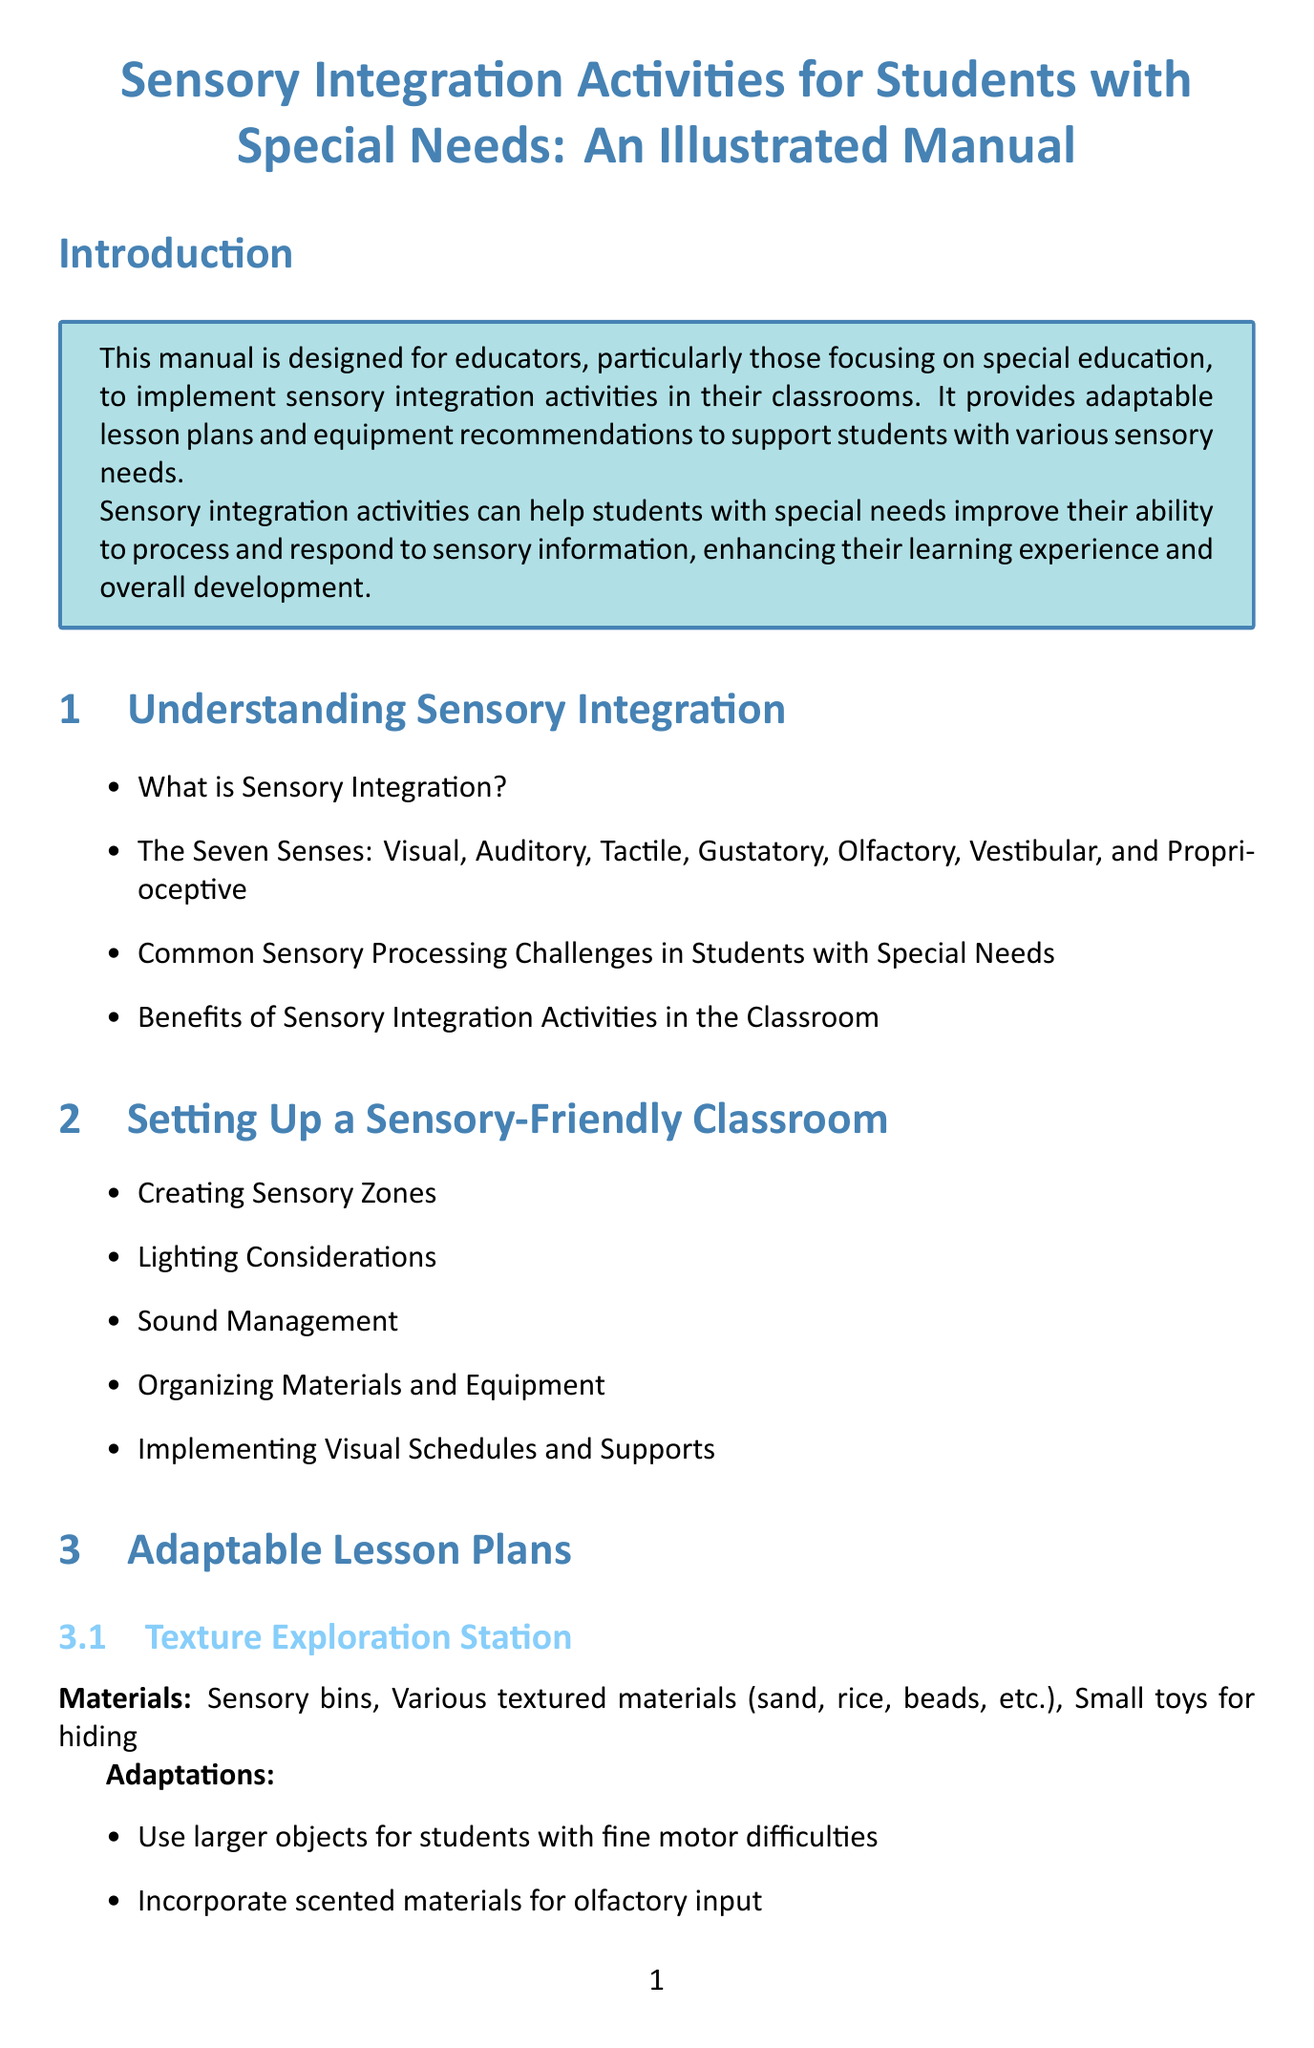What is the title of the manual? The title of the manual is explicitly stated at the beginning of the document.
Answer: Sensory Integration Activities for Students with Special Needs: An Illustrated Manual How many sensory modalities are discussed? The section about the senses specifically mentions the total number of senses.
Answer: Seven Name one material used in the Texture Exploration Station activity. The materials for each activity are listed in their respective sections.
Answer: Sensory bins What adaptation is suggested for students with fine motor difficulties? The adaptations for each lesson plan activity are listed therein.
Answer: Use larger objects Which section covers communication strategies for discussing sensory needs? The document includes a section that pertains specifically to resources for parents and caregivers.
Answer: Parent and Caregiver Resources What is one item recommended for auditory input? The equipment recommendations include categories and items; one item should be indicated from the auditory input category.
Answer: White noise machine In which chapter would you find information about creating sensory zones? The chapter titles direct the reader to specific topics addressed in the manual.
Answer: Setting Up a Sensory-Friendly Classroom What is the focus of the conclusion? The conclusion summarizes the manual's purpose and encourages continued learning among educators.
Answer: Comprehensive guide What should educators continue to explore according to the conclusion? The conclusion contains a call to action for educators, indicating what they should focus on.
Answer: Adapt these strategies 